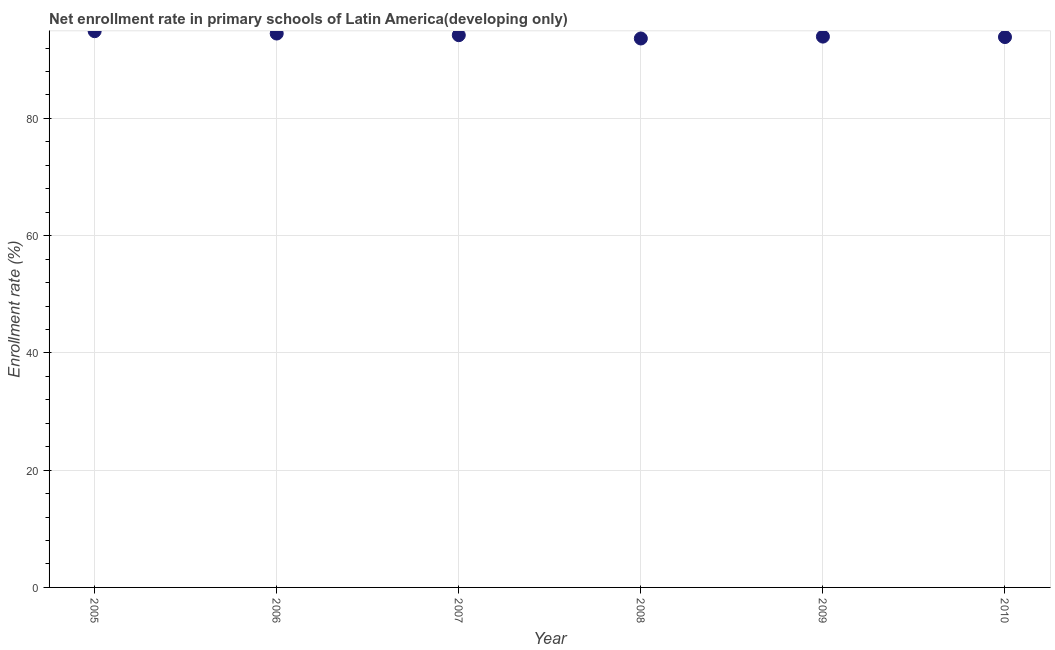What is the net enrollment rate in primary schools in 2010?
Your answer should be compact. 93.88. Across all years, what is the maximum net enrollment rate in primary schools?
Your response must be concise. 94.88. Across all years, what is the minimum net enrollment rate in primary schools?
Keep it short and to the point. 93.64. In which year was the net enrollment rate in primary schools minimum?
Your answer should be very brief. 2008. What is the sum of the net enrollment rate in primary schools?
Give a very brief answer. 565.06. What is the difference between the net enrollment rate in primary schools in 2006 and 2008?
Provide a succinct answer. 0.84. What is the average net enrollment rate in primary schools per year?
Your answer should be very brief. 94.18. What is the median net enrollment rate in primary schools?
Ensure brevity in your answer.  94.08. Do a majority of the years between 2009 and 2006 (inclusive) have net enrollment rate in primary schools greater than 68 %?
Give a very brief answer. Yes. What is the ratio of the net enrollment rate in primary schools in 2008 to that in 2010?
Offer a very short reply. 1. Is the net enrollment rate in primary schools in 2007 less than that in 2009?
Give a very brief answer. No. Is the difference between the net enrollment rate in primary schools in 2007 and 2010 greater than the difference between any two years?
Make the answer very short. No. What is the difference between the highest and the second highest net enrollment rate in primary schools?
Your answer should be compact. 0.4. What is the difference between the highest and the lowest net enrollment rate in primary schools?
Your response must be concise. 1.24. Does the net enrollment rate in primary schools monotonically increase over the years?
Keep it short and to the point. No. How many dotlines are there?
Give a very brief answer. 1. How many years are there in the graph?
Your response must be concise. 6. What is the difference between two consecutive major ticks on the Y-axis?
Provide a succinct answer. 20. Are the values on the major ticks of Y-axis written in scientific E-notation?
Your answer should be compact. No. Does the graph contain grids?
Your answer should be very brief. Yes. What is the title of the graph?
Your answer should be compact. Net enrollment rate in primary schools of Latin America(developing only). What is the label or title of the X-axis?
Make the answer very short. Year. What is the label or title of the Y-axis?
Make the answer very short. Enrollment rate (%). What is the Enrollment rate (%) in 2005?
Provide a succinct answer. 94.88. What is the Enrollment rate (%) in 2006?
Provide a succinct answer. 94.48. What is the Enrollment rate (%) in 2007?
Your answer should be compact. 94.2. What is the Enrollment rate (%) in 2008?
Give a very brief answer. 93.64. What is the Enrollment rate (%) in 2009?
Give a very brief answer. 93.96. What is the Enrollment rate (%) in 2010?
Give a very brief answer. 93.88. What is the difference between the Enrollment rate (%) in 2005 and 2006?
Keep it short and to the point. 0.4. What is the difference between the Enrollment rate (%) in 2005 and 2007?
Ensure brevity in your answer.  0.68. What is the difference between the Enrollment rate (%) in 2005 and 2008?
Your response must be concise. 1.24. What is the difference between the Enrollment rate (%) in 2005 and 2009?
Ensure brevity in your answer.  0.92. What is the difference between the Enrollment rate (%) in 2005 and 2010?
Give a very brief answer. 1. What is the difference between the Enrollment rate (%) in 2006 and 2007?
Your answer should be compact. 0.28. What is the difference between the Enrollment rate (%) in 2006 and 2008?
Offer a very short reply. 0.84. What is the difference between the Enrollment rate (%) in 2006 and 2009?
Provide a succinct answer. 0.52. What is the difference between the Enrollment rate (%) in 2006 and 2010?
Offer a very short reply. 0.6. What is the difference between the Enrollment rate (%) in 2007 and 2008?
Give a very brief answer. 0.57. What is the difference between the Enrollment rate (%) in 2007 and 2009?
Make the answer very short. 0.24. What is the difference between the Enrollment rate (%) in 2007 and 2010?
Ensure brevity in your answer.  0.32. What is the difference between the Enrollment rate (%) in 2008 and 2009?
Your response must be concise. -0.32. What is the difference between the Enrollment rate (%) in 2008 and 2010?
Your answer should be compact. -0.24. What is the difference between the Enrollment rate (%) in 2009 and 2010?
Keep it short and to the point. 0.08. What is the ratio of the Enrollment rate (%) in 2005 to that in 2007?
Offer a terse response. 1.01. What is the ratio of the Enrollment rate (%) in 2005 to that in 2009?
Give a very brief answer. 1.01. What is the ratio of the Enrollment rate (%) in 2005 to that in 2010?
Keep it short and to the point. 1.01. What is the ratio of the Enrollment rate (%) in 2006 to that in 2007?
Provide a short and direct response. 1. What is the ratio of the Enrollment rate (%) in 2006 to that in 2008?
Make the answer very short. 1.01. What is the ratio of the Enrollment rate (%) in 2006 to that in 2009?
Offer a very short reply. 1.01. What is the ratio of the Enrollment rate (%) in 2006 to that in 2010?
Give a very brief answer. 1.01. What is the ratio of the Enrollment rate (%) in 2007 to that in 2008?
Your answer should be compact. 1.01. What is the ratio of the Enrollment rate (%) in 2007 to that in 2009?
Make the answer very short. 1. 